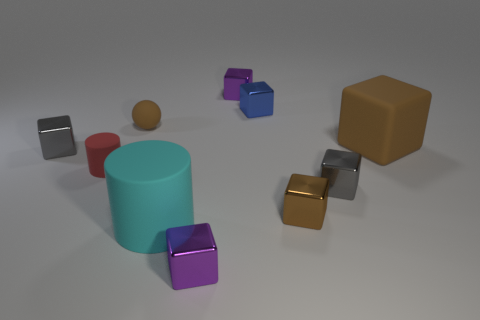Subtract all purple blocks. How many blocks are left? 5 Subtract all big brown cubes. How many cubes are left? 6 Subtract all purple cubes. Subtract all red balls. How many cubes are left? 5 Subtract all balls. How many objects are left? 9 Subtract 1 cyan cylinders. How many objects are left? 9 Subtract all small brown shiny objects. Subtract all tiny purple blocks. How many objects are left? 7 Add 4 blue shiny objects. How many blue shiny objects are left? 5 Add 3 tiny purple blocks. How many tiny purple blocks exist? 5 